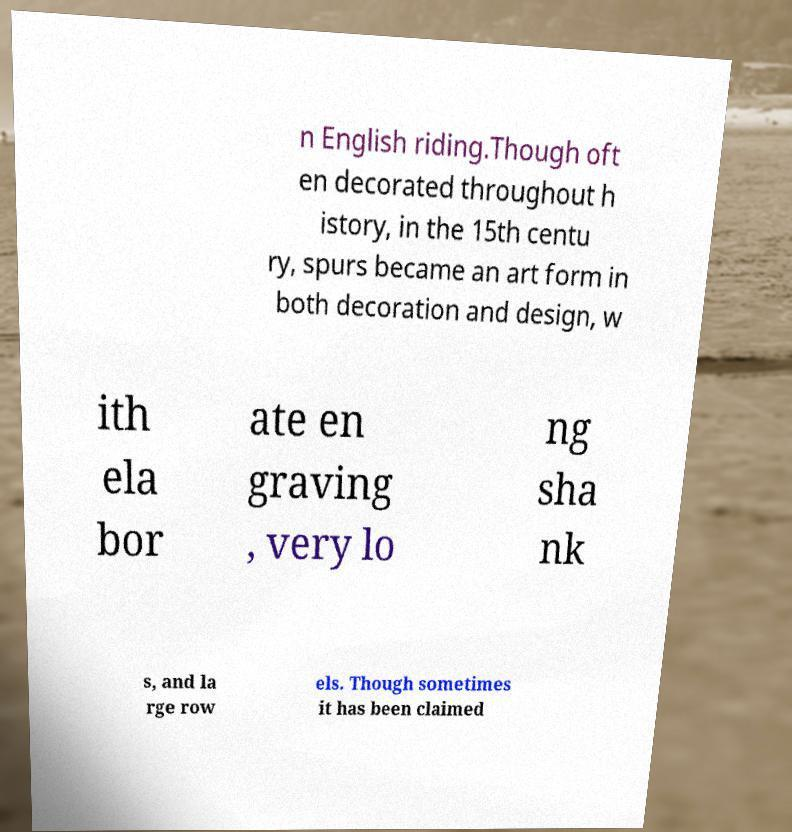What messages or text are displayed in this image? I need them in a readable, typed format. n English riding.Though oft en decorated throughout h istory, in the 15th centu ry, spurs became an art form in both decoration and design, w ith ela bor ate en graving , very lo ng sha nk s, and la rge row els. Though sometimes it has been claimed 